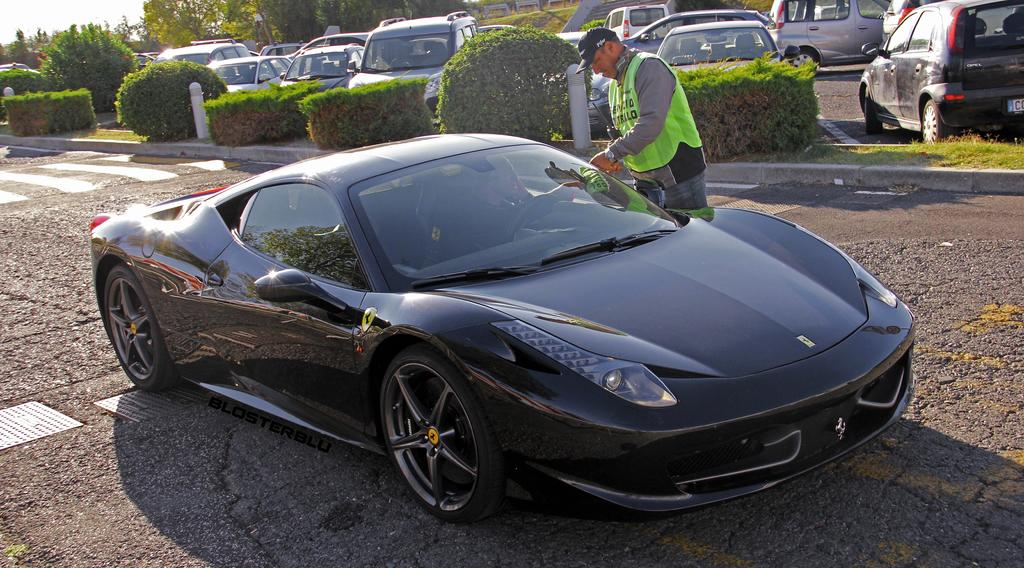What is the main subject in the center of the image? There is a car in the center of the image. Where is the car located? The car is on the road. Can you describe the person in the image? There is a person in the image, but their appearance or actions are not specified. What can be seen in the background of the image? There are cars and plants in the background of the image. What type of mountain can be seen in the background of the image? There is no mountain present in the image; it features a car on the road with cars and plants in the background. 